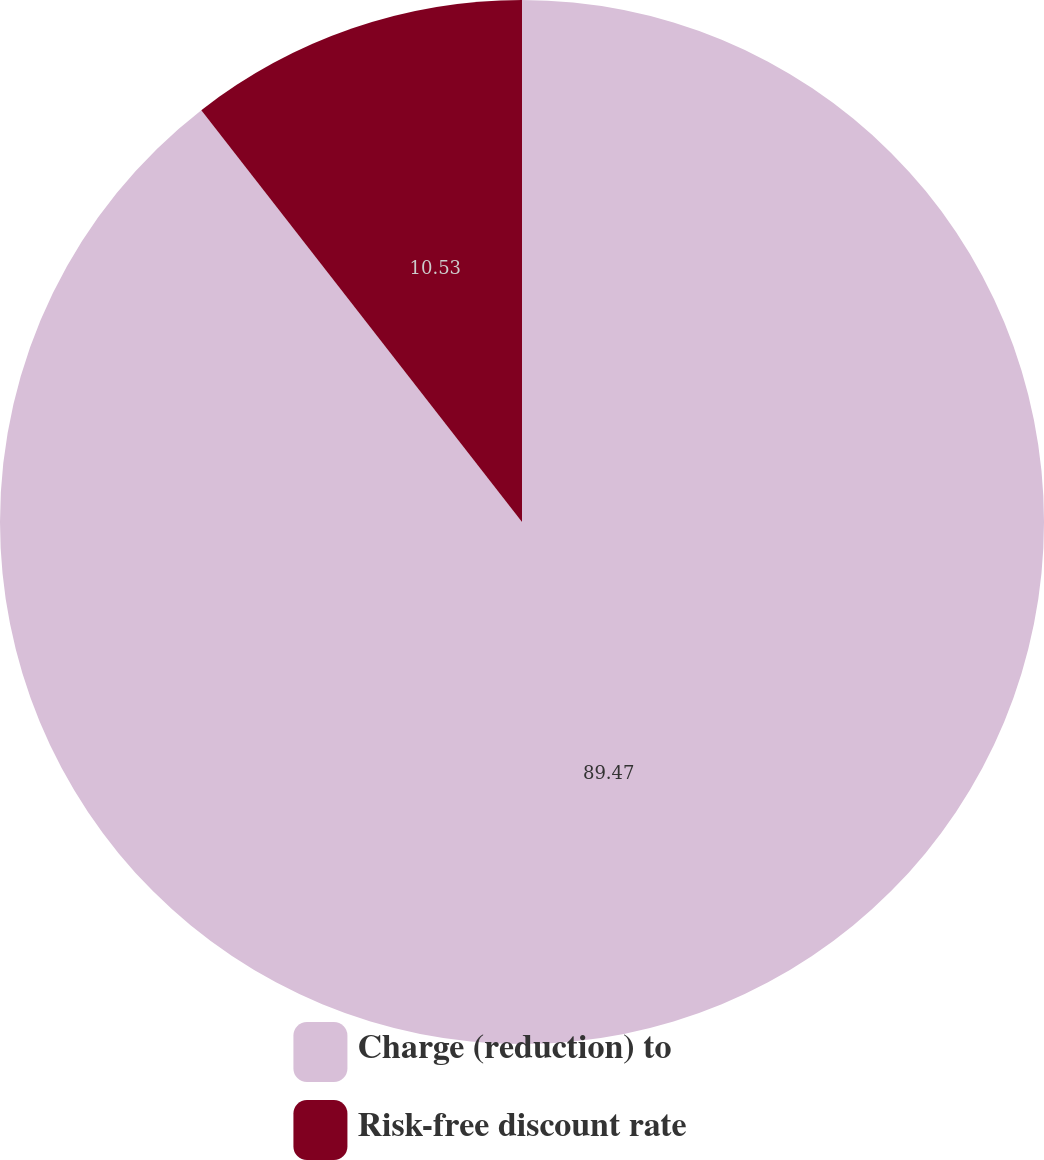Convert chart to OTSL. <chart><loc_0><loc_0><loc_500><loc_500><pie_chart><fcel>Charge (reduction) to<fcel>Risk-free discount rate<nl><fcel>89.47%<fcel>10.53%<nl></chart> 